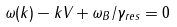<formula> <loc_0><loc_0><loc_500><loc_500>\omega ( { k } ) - k _ { \| } V _ { \| } + \omega _ { B } / \gamma _ { r e s } = 0</formula> 